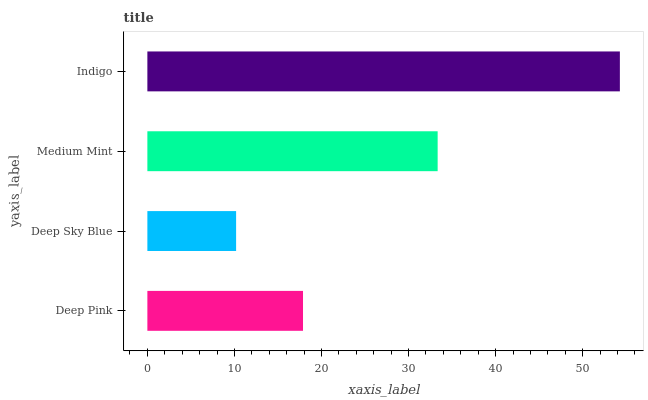Is Deep Sky Blue the minimum?
Answer yes or no. Yes. Is Indigo the maximum?
Answer yes or no. Yes. Is Medium Mint the minimum?
Answer yes or no. No. Is Medium Mint the maximum?
Answer yes or no. No. Is Medium Mint greater than Deep Sky Blue?
Answer yes or no. Yes. Is Deep Sky Blue less than Medium Mint?
Answer yes or no. Yes. Is Deep Sky Blue greater than Medium Mint?
Answer yes or no. No. Is Medium Mint less than Deep Sky Blue?
Answer yes or no. No. Is Medium Mint the high median?
Answer yes or no. Yes. Is Deep Pink the low median?
Answer yes or no. Yes. Is Deep Pink the high median?
Answer yes or no. No. Is Deep Sky Blue the low median?
Answer yes or no. No. 